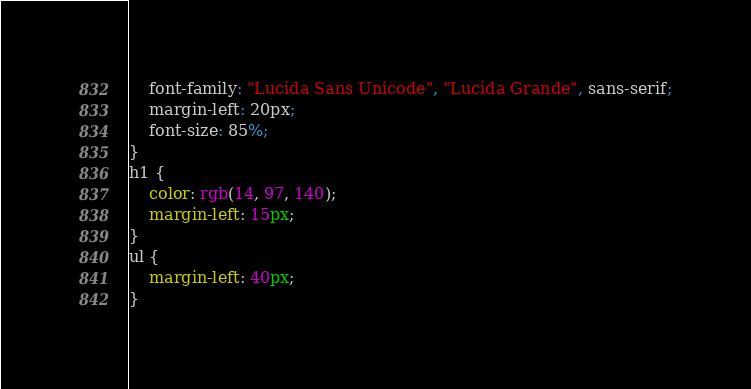<code> <loc_0><loc_0><loc_500><loc_500><_CSS_>    font-family: "Lucida Sans Unicode", "Lucida Grande", sans-serif;
    margin-left: 20px;
    font-size: 85%;
}
h1 {
    color: rgb(14, 97, 140);
    margin-left: 15px;
}
ul {
    margin-left: 40px;
}</code> 